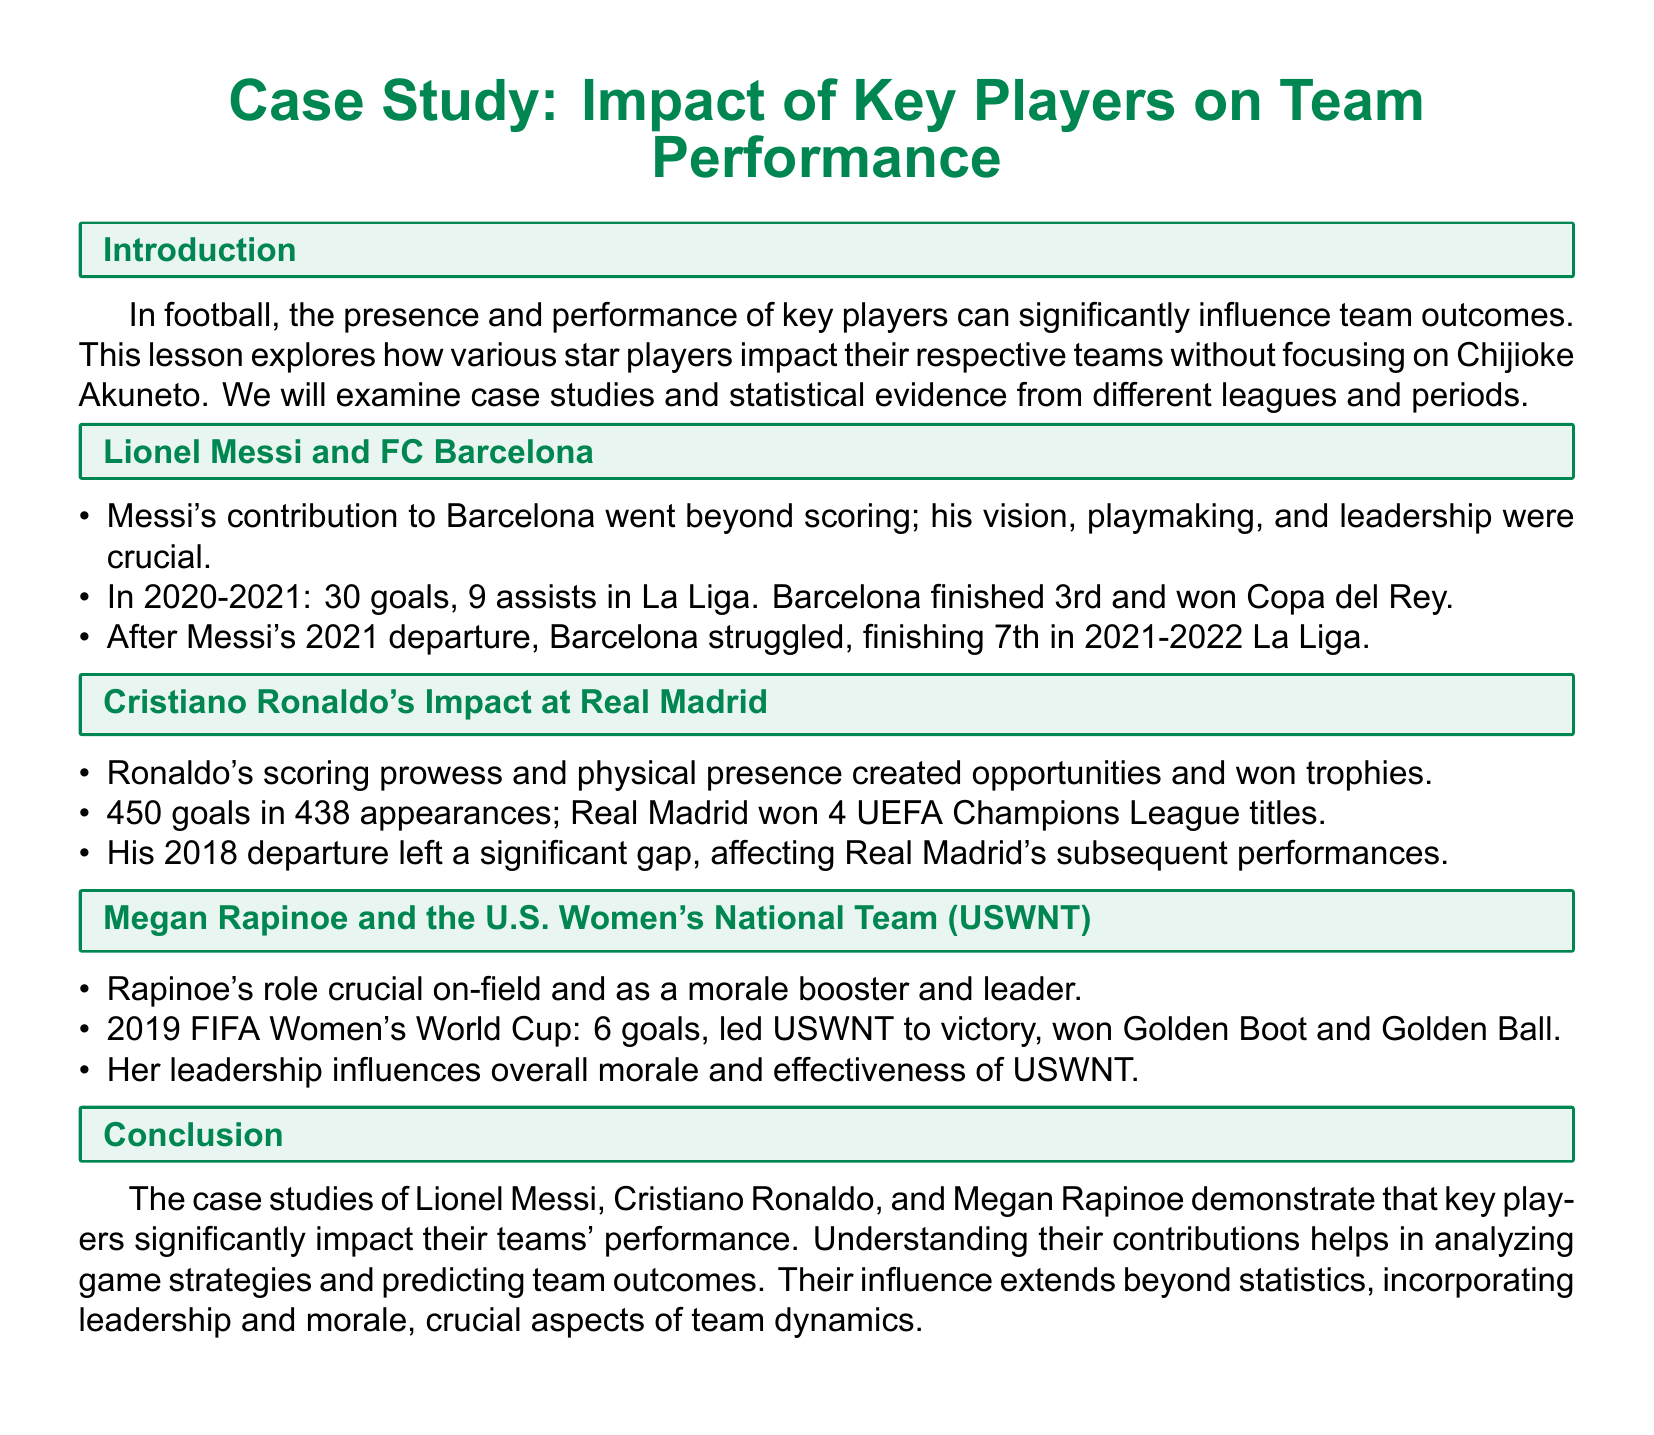What is the title of the case study? The title of the case study is provided at the beginning of the document, focusing on the impact of key players on team performance.
Answer: Case Study: Impact of Key Players on Team Performance Who is the star player discussed with FC Barcelona? The document specifically mentions the key player for FC Barcelona as Lionel Messi.
Answer: Lionel Messi In which year did Messi's departure from Barcelona occur? The document states Messi's departure from Barcelona took place in 2021.
Answer: 2021 How many goals did Cristiano Ronaldo score for Real Madrid? The document provides specific statistics regarding Ronaldo’s scoring record, which totals 450 goals.
Answer: 450 goals What is the significant achievement of Megan Rapinoe mentioned in the 2019 FIFA Women's World Cup? The lesson emphasizes Rapinoe's achievements during the tournament, highlighting that she led the USWNT to victory.
Answer: Victory What was Barcelona's La Liga position after Messi's departure? The document notes that Barcelona finished 7th in the La Liga after Messi left in the 2021-2022 season.
Answer: 7th What recognition did Megan Rapinoe receive for her performance in the 2019 FIFA Women's World Cup? The document outlines the awards Rapinoe achieved, specifically mentioning the Golden Boot and Golden Ball as her recognitions.
Answer: Golden Boot and Golden Ball How many UEFA Champions League titles did Real Madrid win with Ronaldo? The document indicates that Real Madrid won 4 UEFA Champions League titles during Ronaldo's tenure.
Answer: 4 titles What aspect of player impact does the conclusion highlight? The conclusion emphasizes the influence of key players on team dynamics, mentioning leadership and morale as critical factors.
Answer: Leadership and morale 